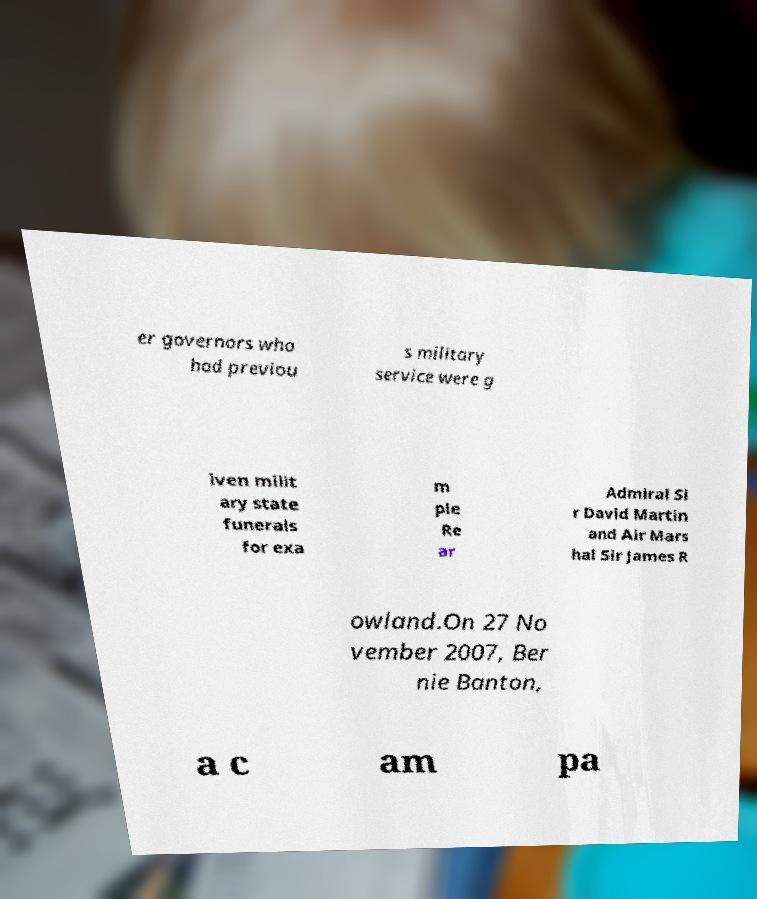Could you extract and type out the text from this image? er governors who had previou s military service were g iven milit ary state funerals for exa m ple Re ar Admiral Si r David Martin and Air Mars hal Sir James R owland.On 27 No vember 2007, Ber nie Banton, a c am pa 